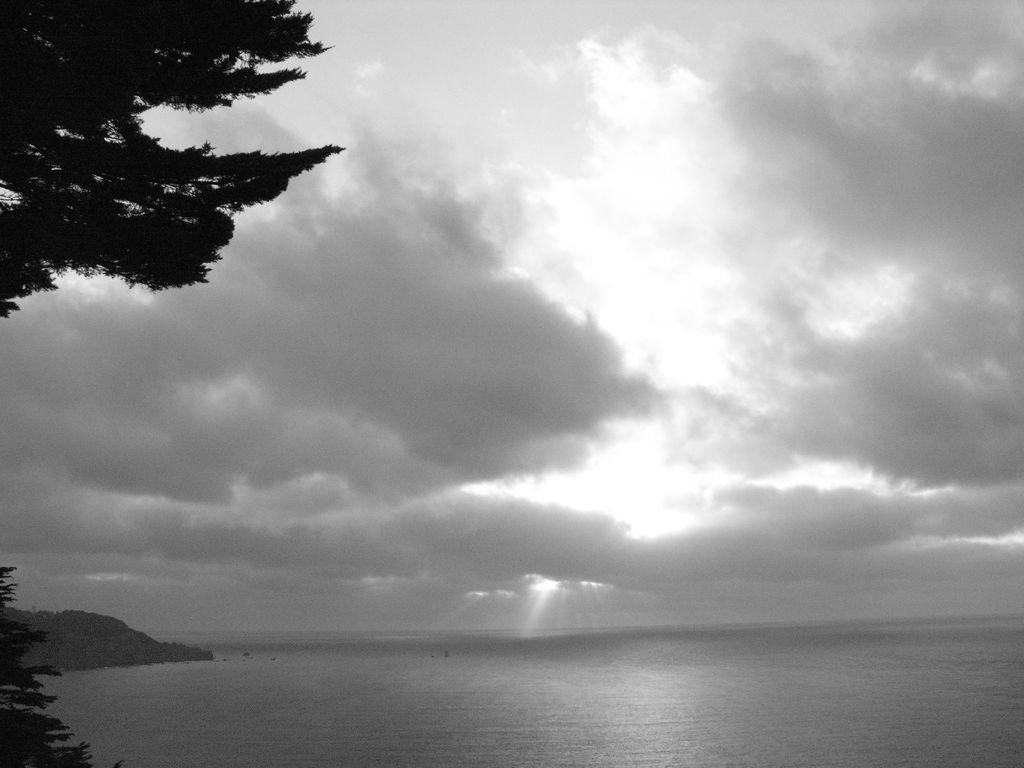What is the primary element visible in the image? There is a water surface in the image. What type of vegetation can be seen on one side of the image? There are trees on the left side of the image. How is the image presented in terms of color? The image is black and white. How many brothers are depicted in the image? There are no people, including brothers, present in the image. What type of medical facility is shown in the image? There is no hospital or any medical facility present in the image. 